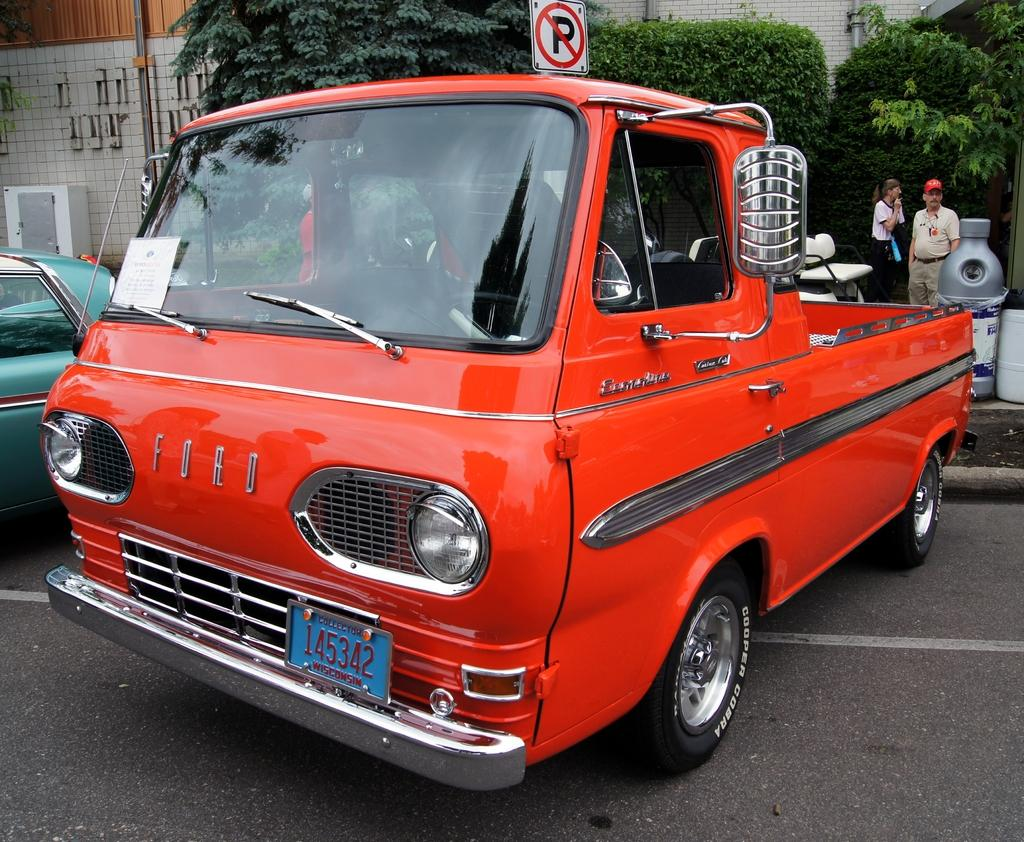<image>
Share a concise interpretation of the image provided. a very old orange Ford vehicle is sitting in a no parking zone 